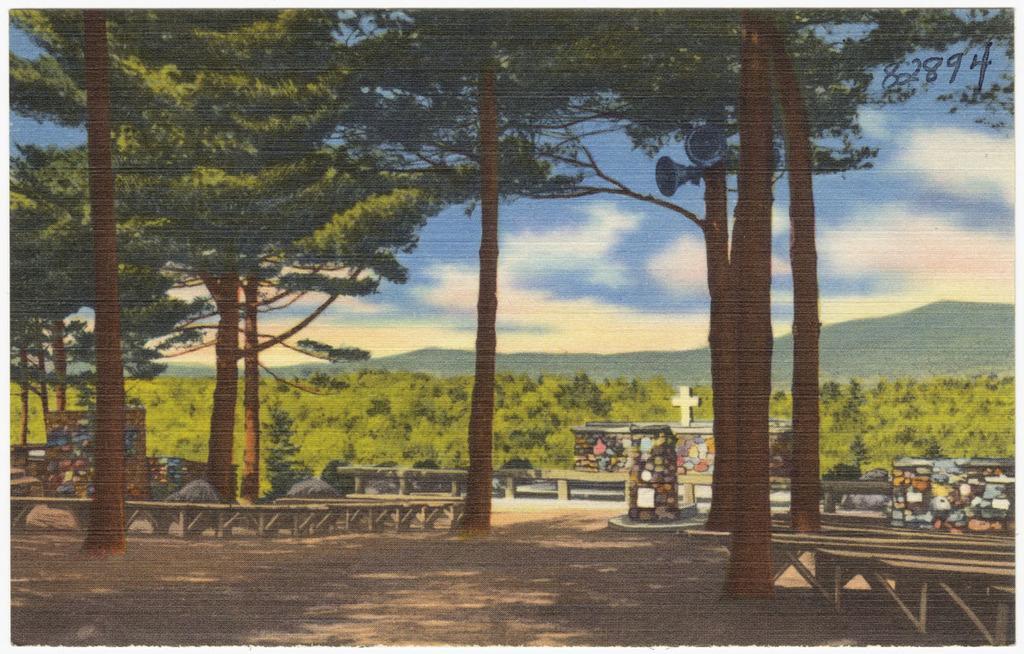Can you describe this image briefly? In this image I can see there are trees, at the top it is the sky. In the middle there are loudspeakers that are connected to this tree, it is a painted image. 